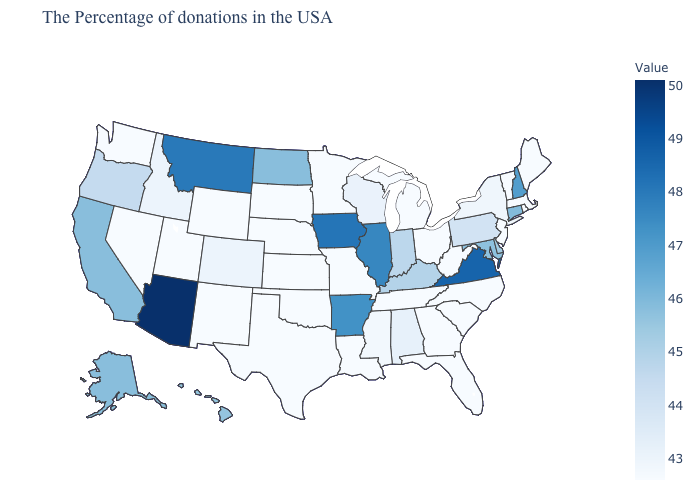Which states hav the highest value in the South?
Give a very brief answer. Virginia. Does Colorado have the lowest value in the West?
Concise answer only. No. Among the states that border Virginia , does Tennessee have the highest value?
Answer briefly. No. Does the map have missing data?
Short answer required. No. Among the states that border Massachusetts , which have the lowest value?
Write a very short answer. Rhode Island, Vermont. 